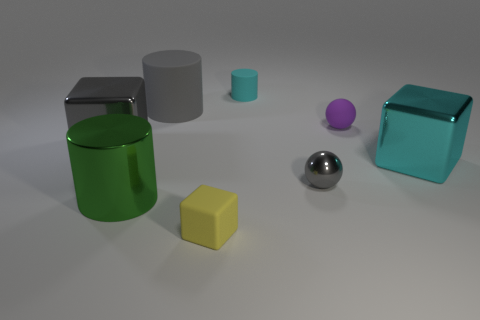Are there any gray cylinders on the left side of the small rubber sphere?
Ensure brevity in your answer.  Yes. There is a cylinder that is behind the cyan block and on the left side of the yellow block; what is it made of?
Offer a very short reply. Rubber. There is a big shiny thing that is the same shape as the cyan matte thing; what is its color?
Ensure brevity in your answer.  Green. Is there a cyan object to the left of the purple sphere behind the small metallic object?
Your answer should be very brief. Yes. The gray cylinder is what size?
Provide a short and direct response. Large. What is the shape of the metallic thing that is to the left of the cyan cube and right of the big matte cylinder?
Give a very brief answer. Sphere. What number of yellow objects are small metal balls or rubber blocks?
Ensure brevity in your answer.  1. Does the block in front of the tiny shiny ball have the same size as the gray metallic object to the left of the cyan cylinder?
Ensure brevity in your answer.  No. How many objects are either small metallic balls or small purple cylinders?
Give a very brief answer. 1. Are there any cyan things of the same shape as the big green object?
Offer a terse response. Yes. 